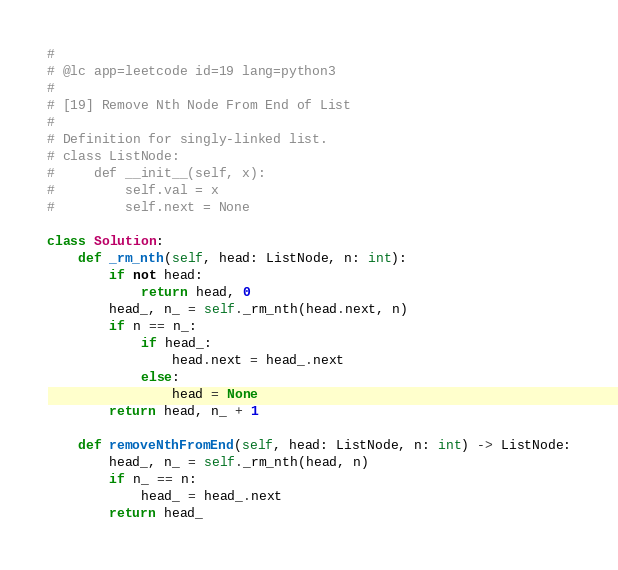<code> <loc_0><loc_0><loc_500><loc_500><_Python_>#
# @lc app=leetcode id=19 lang=python3
#
# [19] Remove Nth Node From End of List
#
# Definition for singly-linked list.
# class ListNode:
#     def __init__(self, x):
#         self.val = x
#         self.next = None

class Solution:
    def _rm_nth(self, head: ListNode, n: int):
        if not head:
            return head, 0
        head_, n_ = self._rm_nth(head.next, n)
        if n == n_:
            if head_:
                head.next = head_.next
            else:
                head = None
        return head, n_ + 1

    def removeNthFromEnd(self, head: ListNode, n: int) -> ListNode:
        head_, n_ = self._rm_nth(head, n)
        if n_ == n:
            head_ = head_.next
        return head_
</code> 